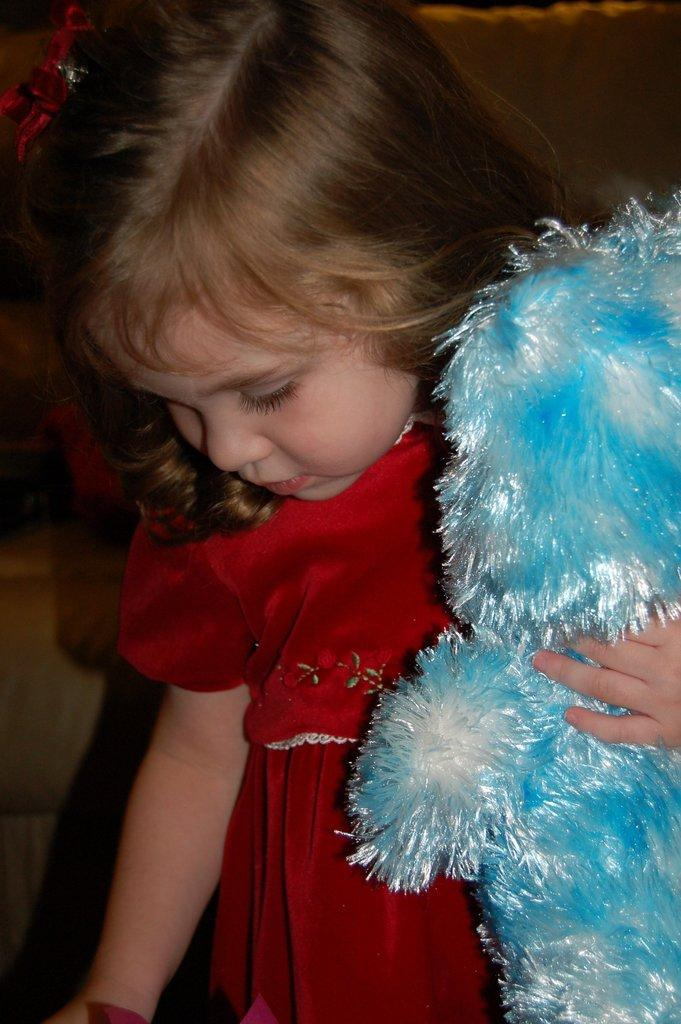What is the main subject of the image? The main subject of the image is a child. What is the child holding in the image? The child is holding a toy in the image. What color is the child's dress? The child is wearing a red dress. What colors are present on the toy? The toy is in white and blue colors. Is there an iron visible in the image? No, there is no iron present in the image. Can you see the child's parent in the image? The provided facts do not mention the presence of a parent in the image. 